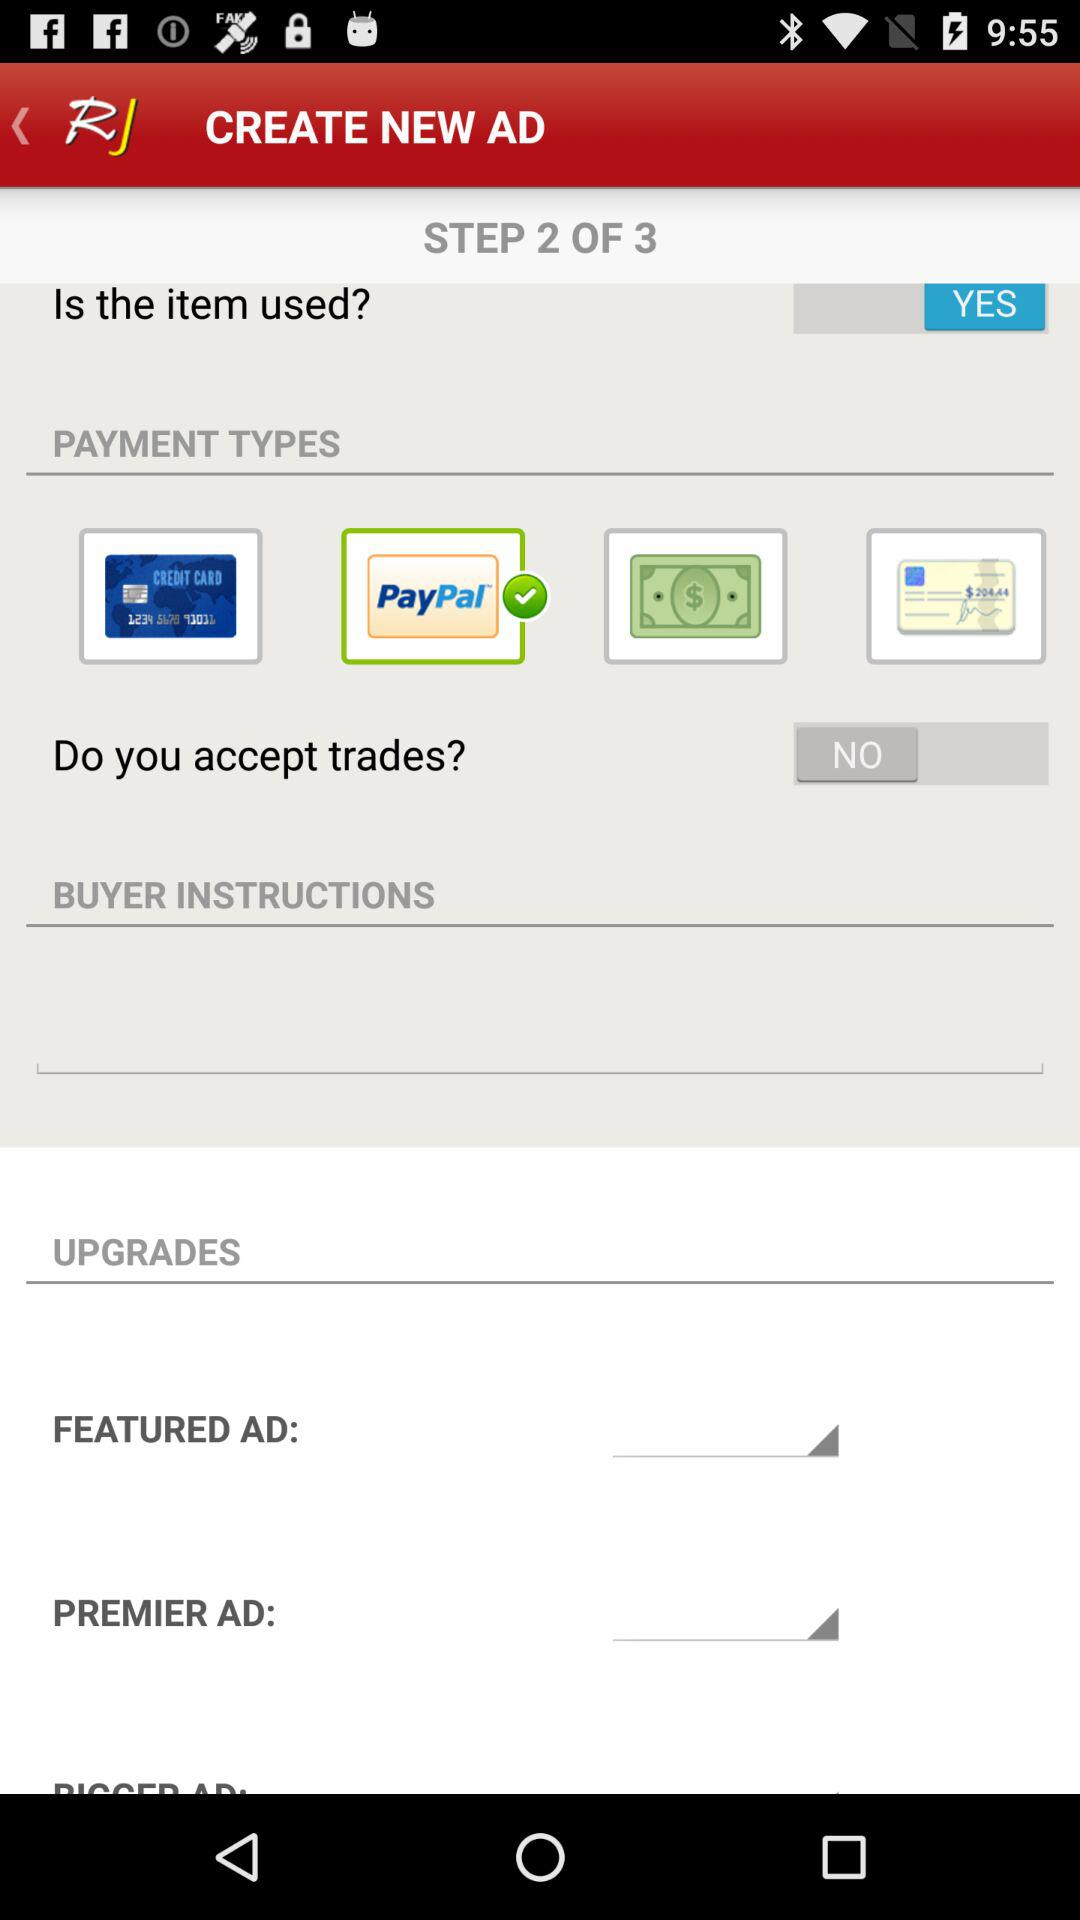How many payment options are available?
Answer the question using a single word or phrase. 4 